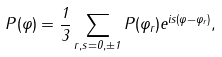Convert formula to latex. <formula><loc_0><loc_0><loc_500><loc_500>P ( \varphi ) = \frac { 1 } { 3 } \sum _ { r , s = 0 , \pm 1 } P ( \varphi _ { r } ) e ^ { i s ( \varphi - \varphi _ { r } ) } ,</formula> 